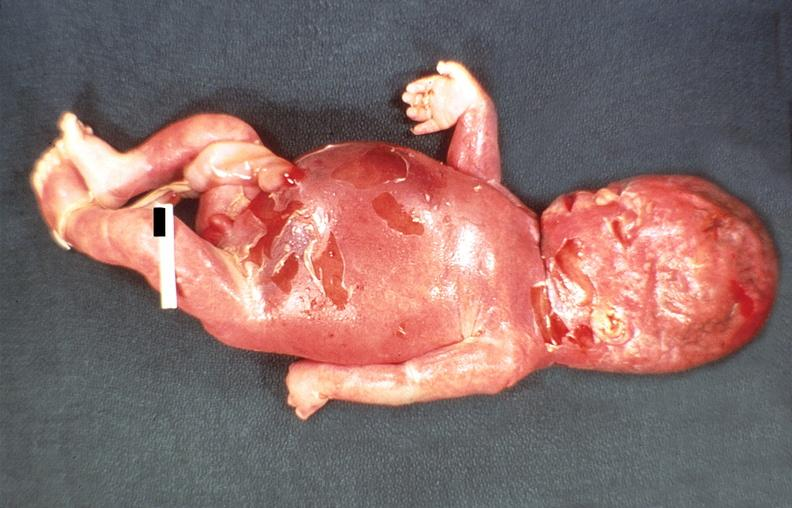does acid show hemolytic disease of newborn?
Answer the question using a single word or phrase. No 